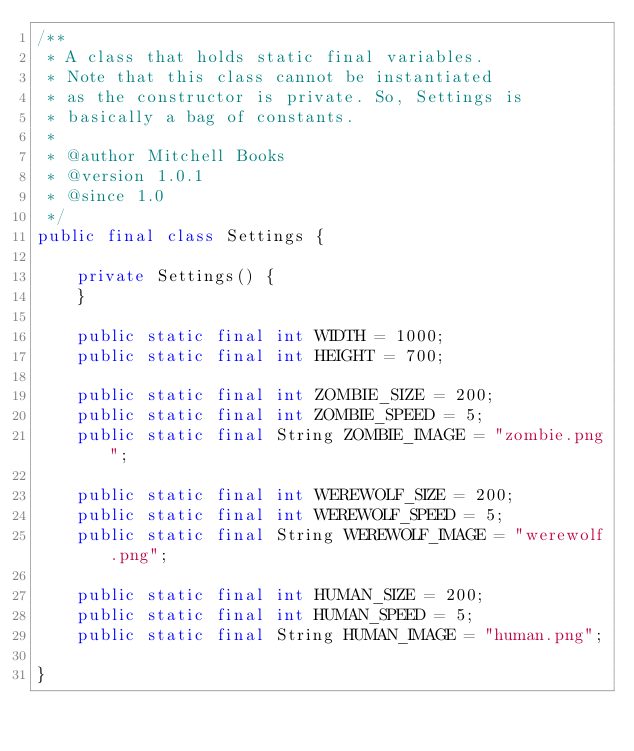Convert code to text. <code><loc_0><loc_0><loc_500><loc_500><_Java_>/**
 * A class that holds static final variables.
 * Note that this class cannot be instantiated
 * as the constructor is private. So, Settings is
 * basically a bag of constants.
 *
 * @author Mitchell Books
 * @version 1.0.1
 * @since 1.0
 */
public final class Settings {

    private Settings() {
    }

    public static final int WIDTH = 1000;
    public static final int HEIGHT = 700;

    public static final int ZOMBIE_SIZE = 200;
    public static final int ZOMBIE_SPEED = 5;
    public static final String ZOMBIE_IMAGE = "zombie.png";

    public static final int WEREWOLF_SIZE = 200;
    public static final int WEREWOLF_SPEED = 5;
    public static final String WEREWOLF_IMAGE = "werewolf.png";

    public static final int HUMAN_SIZE = 200;
    public static final int HUMAN_SPEED = 5;
    public static final String HUMAN_IMAGE = "human.png";

}
</code> 